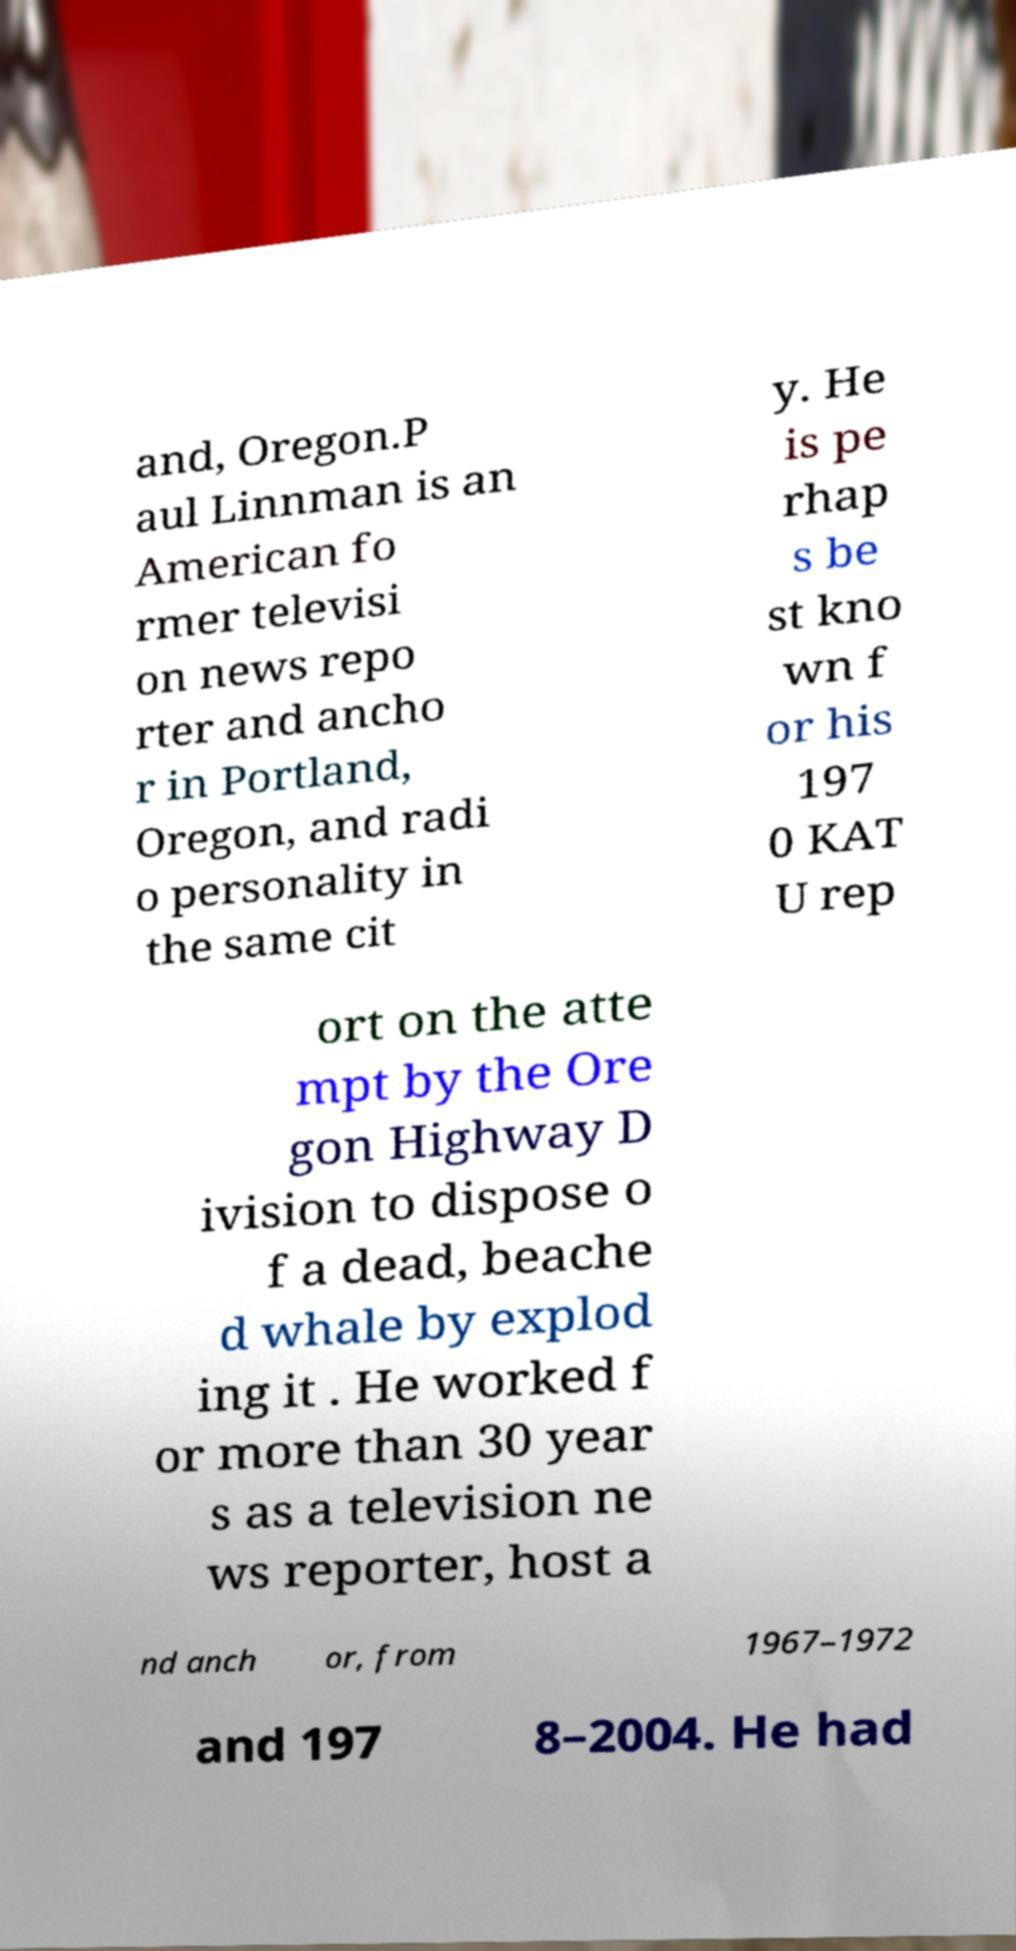There's text embedded in this image that I need extracted. Can you transcribe it verbatim? and, Oregon.P aul Linnman is an American fo rmer televisi on news repo rter and ancho r in Portland, Oregon, and radi o personality in the same cit y. He is pe rhap s be st kno wn f or his 197 0 KAT U rep ort on the atte mpt by the Ore gon Highway D ivision to dispose o f a dead, beache d whale by explod ing it . He worked f or more than 30 year s as a television ne ws reporter, host a nd anch or, from 1967–1972 and 197 8–2004. He had 